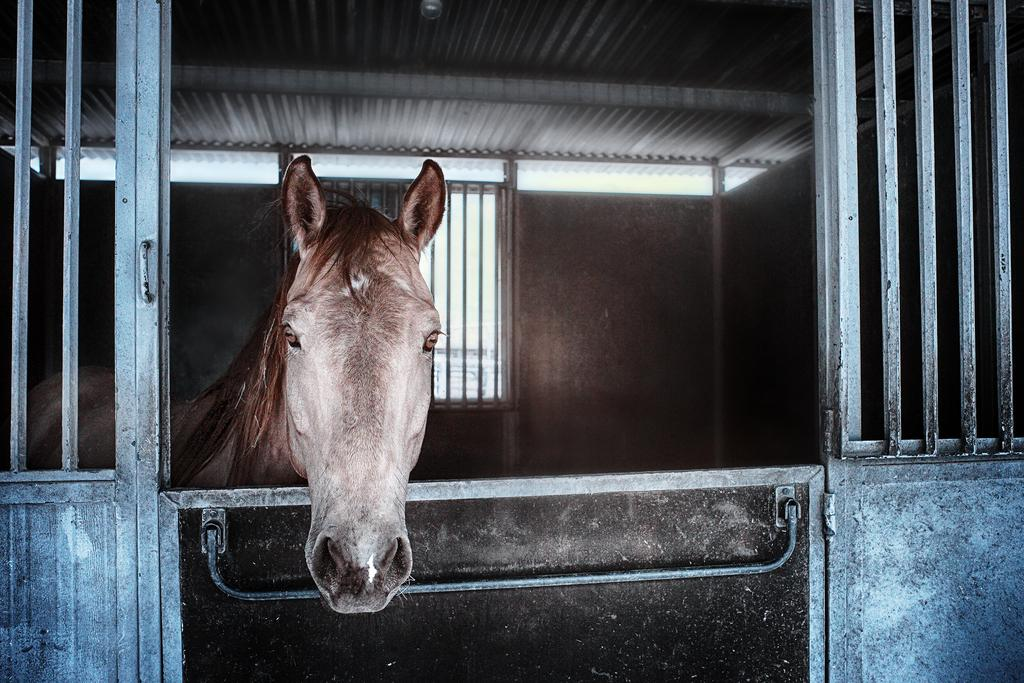What animal is present in the image? There is a horse in the image. What type of material can be seen in the image? There are iron bars in the image. How many legs does the roof have in the image? There is no roof present in the image, so it is not possible to determine how many legs it might have. 